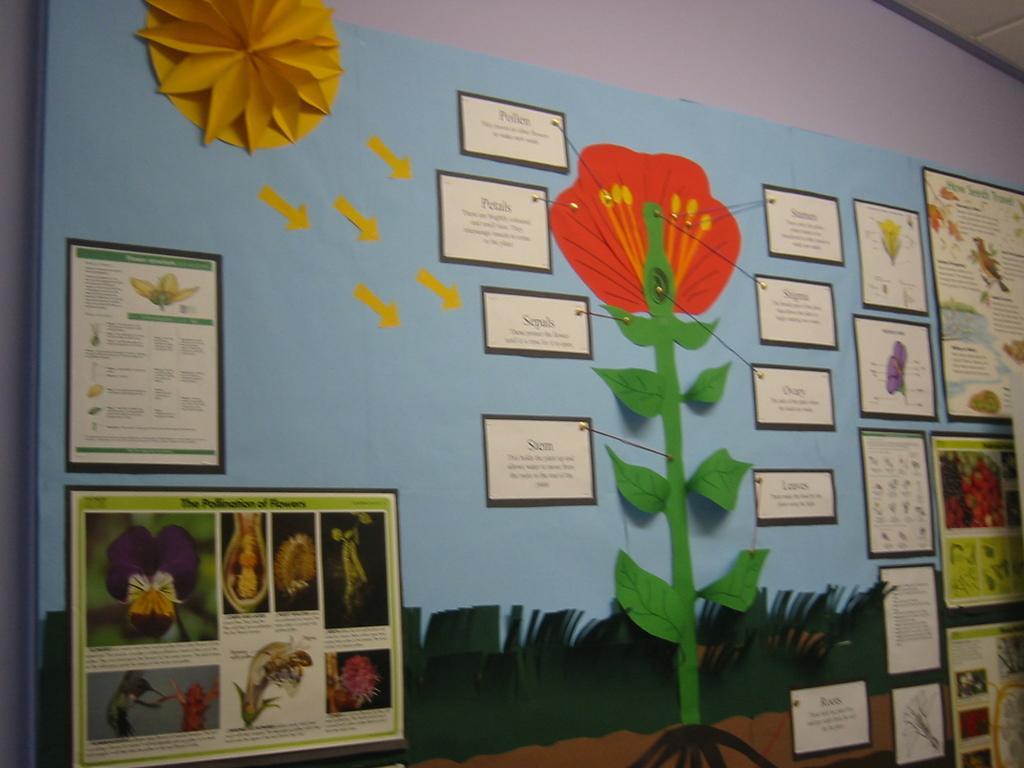How would you summarize this image in a sentence or two? In this image in the center there is one chart, on the chart there are some flowers and some text and in the background there is a wall. 